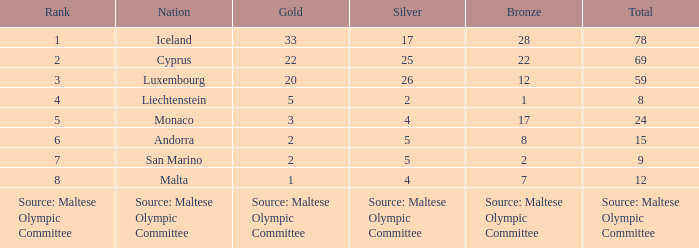For the country possessing 5 gold medals, what is their complete medal tally? 8.0. Write the full table. {'header': ['Rank', 'Nation', 'Gold', 'Silver', 'Bronze', 'Total'], 'rows': [['1', 'Iceland', '33', '17', '28', '78'], ['2', 'Cyprus', '22', '25', '22', '69'], ['3', 'Luxembourg', '20', '26', '12', '59'], ['4', 'Liechtenstein', '5', '2', '1', '8'], ['5', 'Monaco', '3', '4', '17', '24'], ['6', 'Andorra', '2', '5', '8', '15'], ['7', 'San Marino', '2', '5', '2', '9'], ['8', 'Malta', '1', '4', '7', '12'], ['Source: Maltese Olympic Committee', 'Source: Maltese Olympic Committee', 'Source: Maltese Olympic Committee', 'Source: Maltese Olympic Committee', 'Source: Maltese Olympic Committee', 'Source: Maltese Olympic Committee']]} 